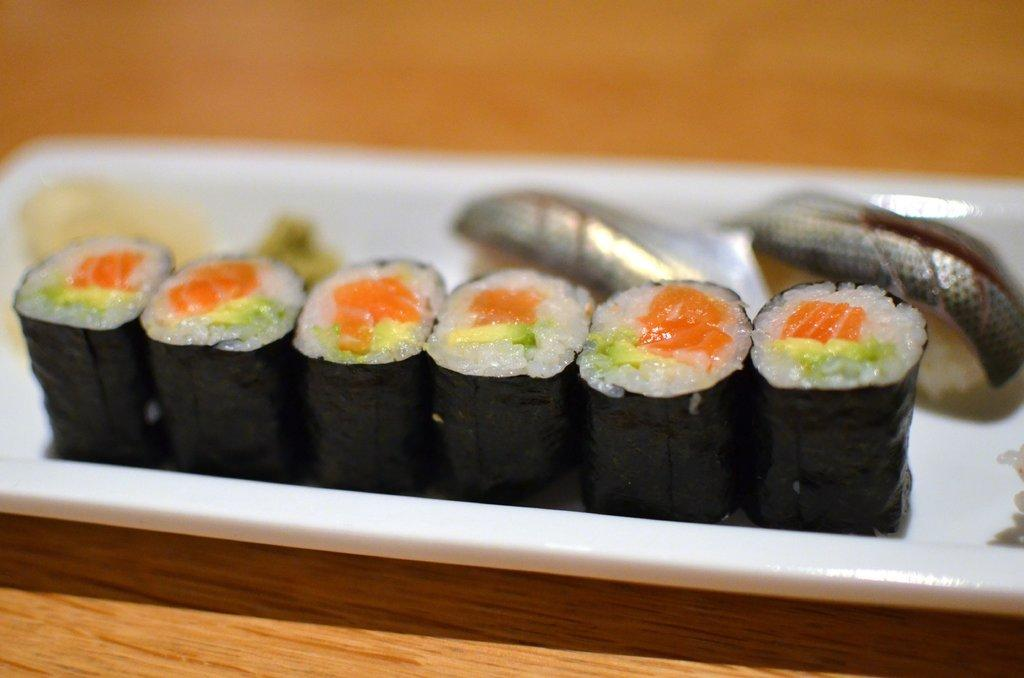What is located in the foreground of the image? There is a plate in the foreground of the image. What can be seen inside the plate? There are six black covers inside the plate. How does the glue help in the digestion process of the things inside the plate? There is no glue or digestion process mentioned in the image. The image only shows a plate with six black covers inside it. 